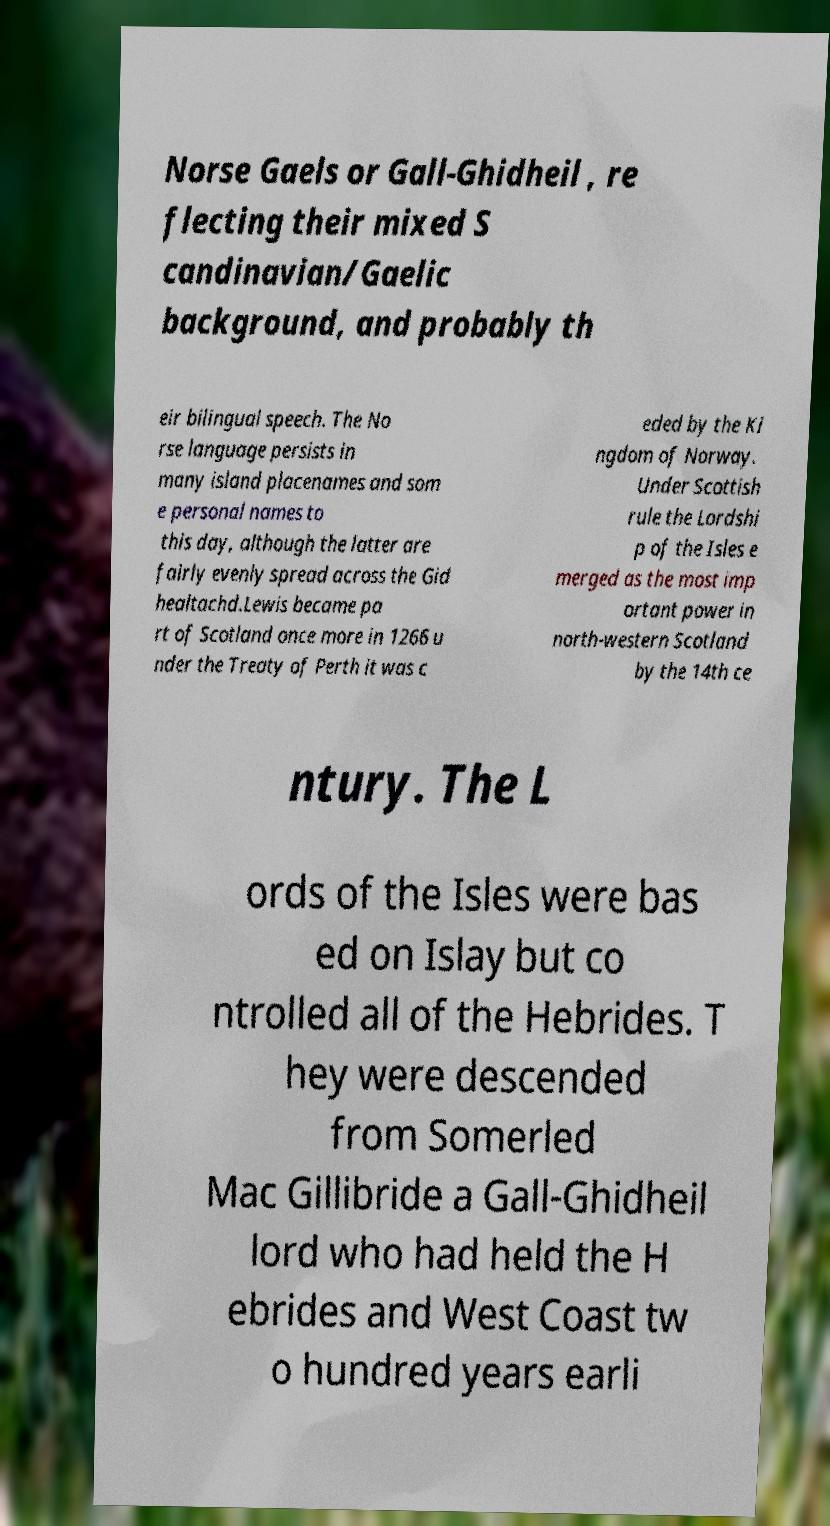Please read and relay the text visible in this image. What does it say? Norse Gaels or Gall-Ghidheil , re flecting their mixed S candinavian/Gaelic background, and probably th eir bilingual speech. The No rse language persists in many island placenames and som e personal names to this day, although the latter are fairly evenly spread across the Gid healtachd.Lewis became pa rt of Scotland once more in 1266 u nder the Treaty of Perth it was c eded by the Ki ngdom of Norway. Under Scottish rule the Lordshi p of the Isles e merged as the most imp ortant power in north-western Scotland by the 14th ce ntury. The L ords of the Isles were bas ed on Islay but co ntrolled all of the Hebrides. T hey were descended from Somerled Mac Gillibride a Gall-Ghidheil lord who had held the H ebrides and West Coast tw o hundred years earli 